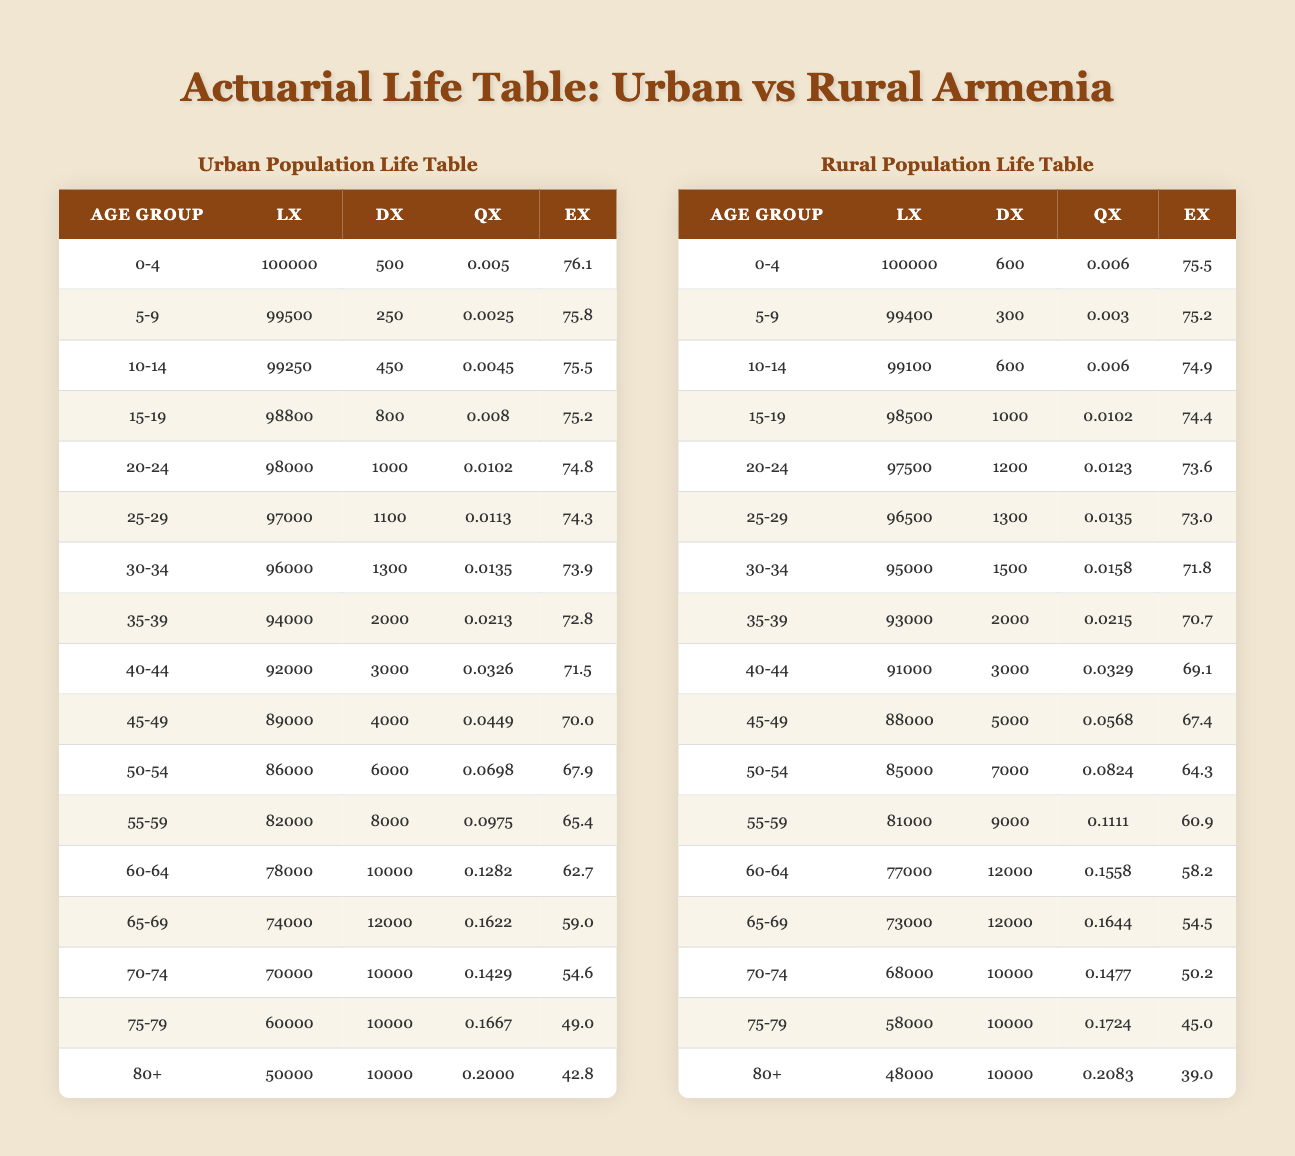What is the life expectancy at age 0 for the urban population in Armenia? The life expectancy at age 0 (ex) for the urban population is found in the "ex" column for the age group 0-4. Referencing the table, the value is 76.1 years.
Answer: 76.1 What is the death rate (qx) for the age group 70-74 in the rural population? To find the death rate (qx) for the rural population in the age group 70-74, locate the "qx" column and the corresponding row for 70-74 in the rural population table. The value is 0.1477.
Answer: 0.1477 How many individuals in the rural population die between the ages 30-34? The number of individuals who die in the rural population between the ages 30-34 is found in the "dx" column for that age group. Referring to the table under rural, the value is 1500.
Answer: 1500 Which age group in the urban population has the highest death rate (qx)? To determine which age group has the highest death rate (qx) in the urban population, examine the "qx" values from each age group and find the maximum. The highest value is 0.2000 for the age group 80+.
Answer: 80+ Is the life expectancy (ex) higher for the urban population compared to the rural population at age 60? At age 60, the life expectancy for the urban population is 62.7 years (ex from urban) and for the rural population is 58.2 years (ex from rural). Comparing the two values shows that 62.7 is greater than 58.2, confirming the urban population has a higher life expectancy at this age.
Answer: Yes What is the total number of individuals (lx) alive in the rural population at age 50-54? The total number of individuals alive (lx) at age 50-54 in the rural population is found in the corresponding row of the "lx" column. Referring to the table, the value is 85000.
Answer: 85000 What is the difference in life expectancy at age 75 between the urban and rural populations? For age 75, the life expectancy for the urban population is 49.0 years and for the rural population is 45.0 years. The difference is calculated as 49.0 - 45.0 = 4.0 years.
Answer: 4.0 How many more deaths (dx) occur in the urban population at age 55-59 than in the rural population for the same age group? The deaths at age 55-59 for the urban population is 8000 and for the rural is 9000. To find the difference, we calculate 8000 - 9000 = -1000. This indicates that there are 1000 more deaths in the rural population than in the urban population at this age.
Answer: 1000 more in rural 